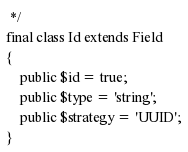Convert code to text. <code><loc_0><loc_0><loc_500><loc_500><_PHP_> */
final class Id extends Field
{
    public $id = true;
    public $type = 'string';
    public $strategy = 'UUID';
}
</code> 